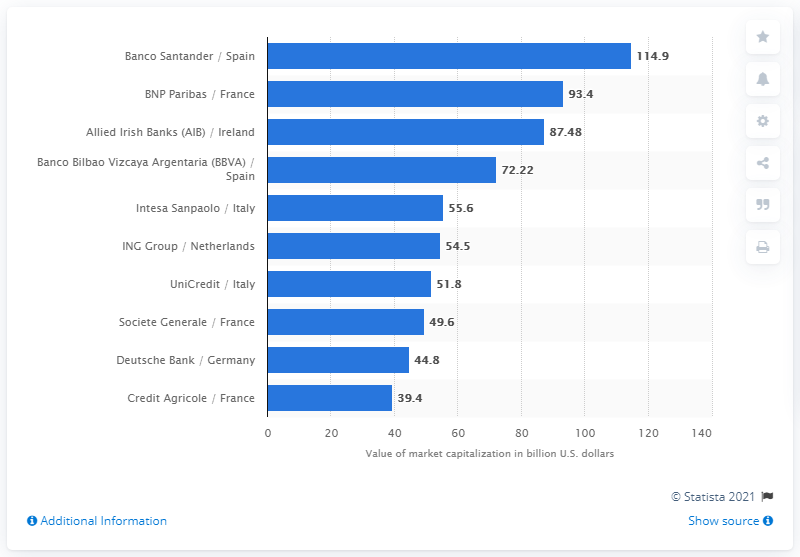Give some essential details in this illustration. The market capitalization value of Spanish Banco Santander was 114.9 billion as of [insert date]. 